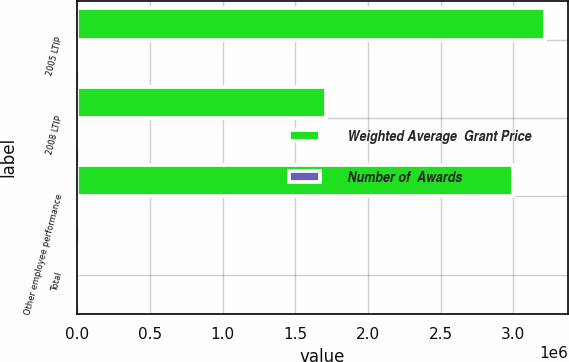<chart> <loc_0><loc_0><loc_500><loc_500><stacked_bar_chart><ecel><fcel>2005 LTIP<fcel>2008 LTIP<fcel>Other employee performance<fcel>Total<nl><fcel>Weighted Average  Grant Price<fcel>3.2145e+06<fcel>1.71475e+06<fcel>3e+06<fcel>21.16<nl><fcel>Number of  Awards<fcel>21.1<fcel>10.59<fcel>21.16<fcel>18.85<nl></chart> 